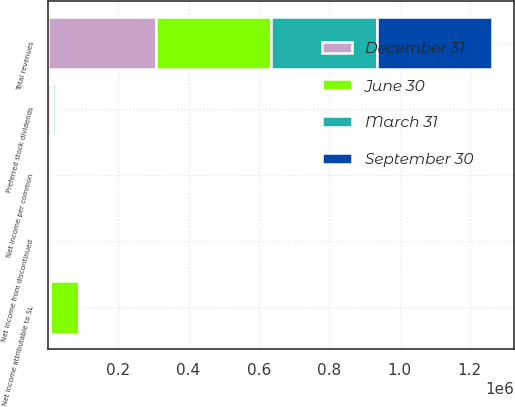Convert chart to OTSL. <chart><loc_0><loc_0><loc_500><loc_500><stacked_bar_chart><ecel><fcel>Total revenues<fcel>Net income from discontinued<fcel>Preferred stock dividends<fcel>Net income attributable to SL<fcel>Net income per common<nl><fcel>September 30<fcel>328877<fcel>1116<fcel>7543<fcel>2808<fcel>0.03<nl><fcel>December 31<fcel>306624<fcel>1116<fcel>7545<fcel>7079<fcel>0.08<nl><fcel>March 31<fcel>298705<fcel>1675<fcel>7545<fcel>1873<fcel>6.26<nl><fcel>June 30<fcel>329222<fcel>1873<fcel>7545<fcel>80887<fcel>1.01<nl></chart> 